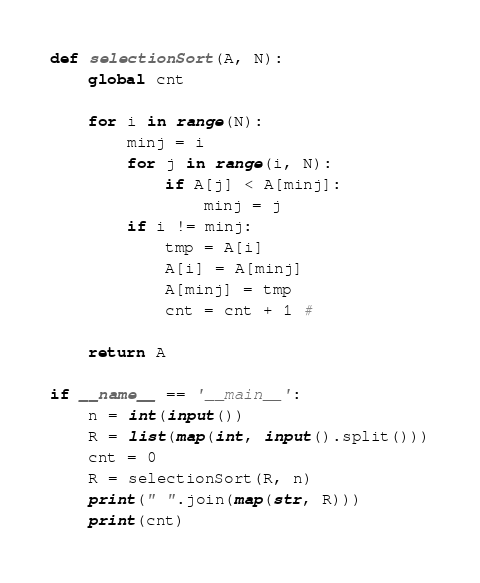Convert code to text. <code><loc_0><loc_0><loc_500><loc_500><_Python_>
def selectionSort(A, N):
	global cnt

	for i in range(N):
		minj = i
		for j in range(i, N):
			if A[j] < A[minj]:
				minj = j
		if i != minj:
			tmp = A[i]
			A[i] = A[minj]
			A[minj] = tmp
			cnt = cnt + 1 #

	return A

if __name__ == '__main__':
	n = int(input())
	R = list(map(int, input().split()))
	cnt = 0
	R = selectionSort(R, n)
	print(" ".join(map(str, R)))
	print(cnt)
</code> 